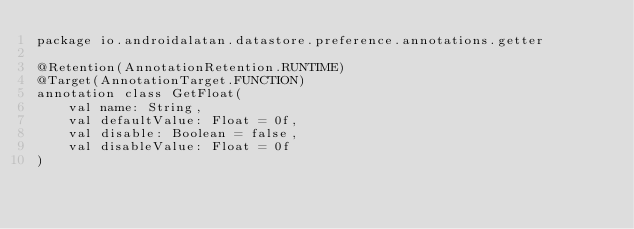<code> <loc_0><loc_0><loc_500><loc_500><_Kotlin_>package io.androidalatan.datastore.preference.annotations.getter

@Retention(AnnotationRetention.RUNTIME)
@Target(AnnotationTarget.FUNCTION)
annotation class GetFloat(
    val name: String,
    val defaultValue: Float = 0f,
    val disable: Boolean = false,
    val disableValue: Float = 0f
)</code> 